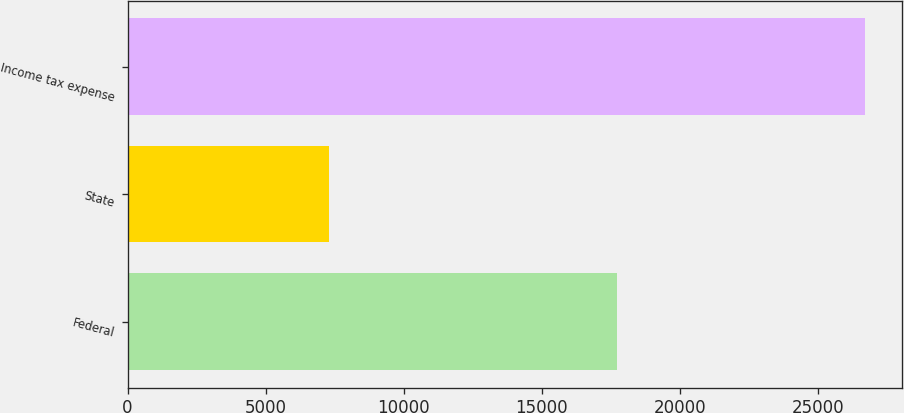<chart> <loc_0><loc_0><loc_500><loc_500><bar_chart><fcel>Federal<fcel>State<fcel>Income tax expense<nl><fcel>17746<fcel>7286<fcel>26719<nl></chart> 